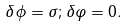<formula> <loc_0><loc_0><loc_500><loc_500>\delta \phi = \sigma ; \delta \varphi = 0 .</formula> 